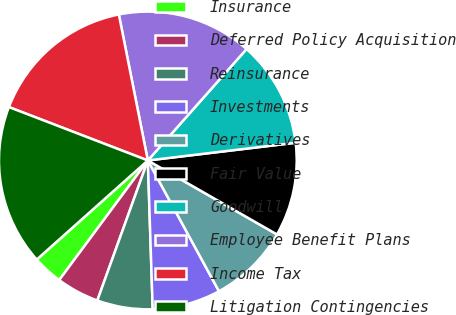Convert chart. <chart><loc_0><loc_0><loc_500><loc_500><pie_chart><fcel>Insurance<fcel>Deferred Policy Acquisition<fcel>Reinsurance<fcel>Investments<fcel>Derivatives<fcel>Fair Value<fcel>Goodwill<fcel>Employee Benefit Plans<fcel>Income Tax<fcel>Litigation Contingencies<nl><fcel>3.26%<fcel>4.64%<fcel>6.03%<fcel>7.41%<fcel>8.79%<fcel>10.18%<fcel>11.56%<fcel>14.66%<fcel>16.04%<fcel>17.43%<nl></chart> 